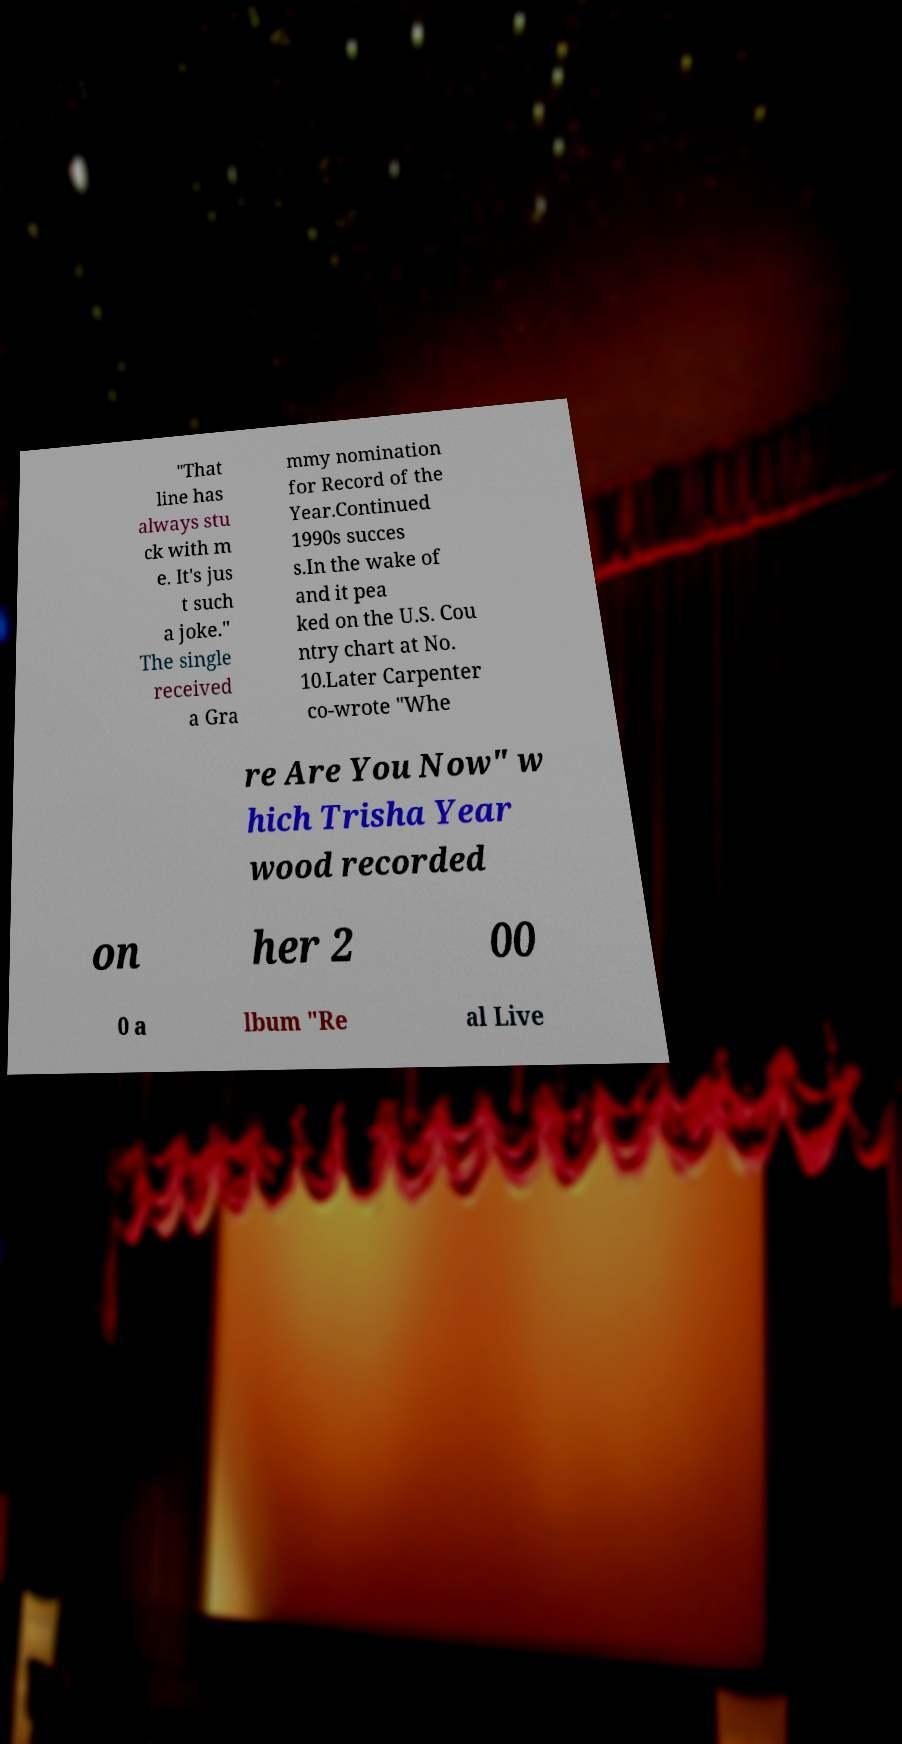For documentation purposes, I need the text within this image transcribed. Could you provide that? "That line has always stu ck with m e. It's jus t such a joke." The single received a Gra mmy nomination for Record of the Year.Continued 1990s succes s.In the wake of and it pea ked on the U.S. Cou ntry chart at No. 10.Later Carpenter co-wrote "Whe re Are You Now" w hich Trisha Year wood recorded on her 2 00 0 a lbum "Re al Live 